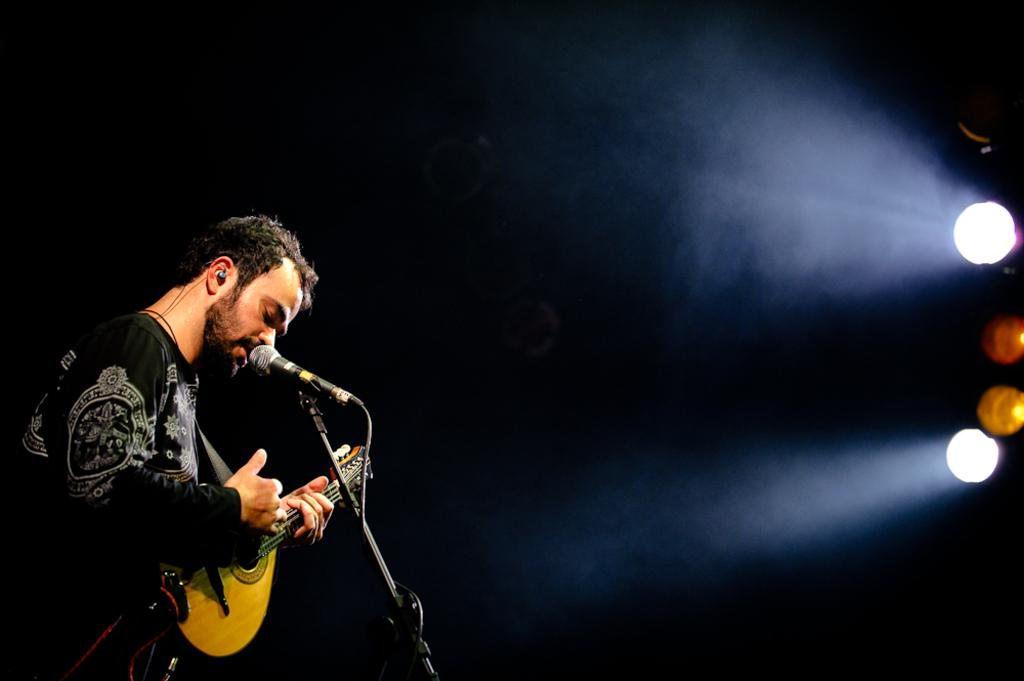What is the man in the image holding? The man is holding a guitar. What activity is the man engaged in? The man is singing on a mic. What can be seen on the left side of the image? There are lights on the left side of the image. What type of drug is the man taking in the image? There is no indication in the image that the man is taking any drug. What type of berry can be seen growing on the mic? There are no berries present on the mic in the image. 